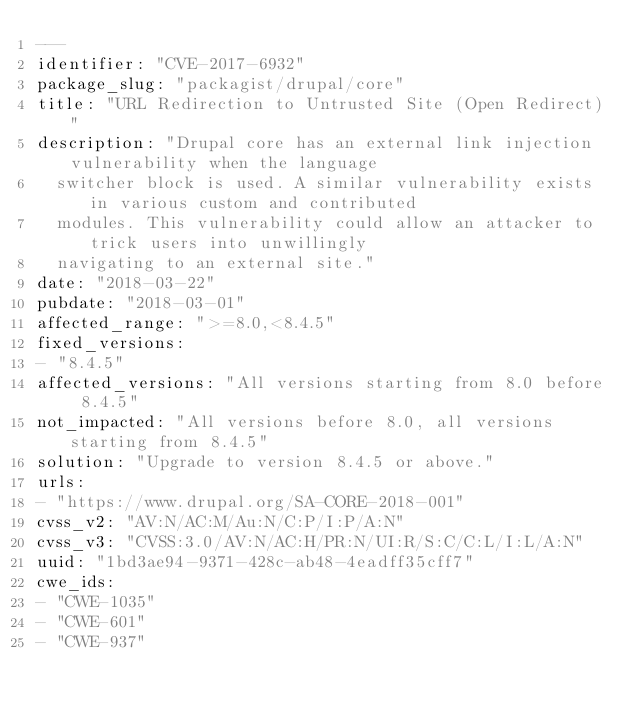Convert code to text. <code><loc_0><loc_0><loc_500><loc_500><_YAML_>---
identifier: "CVE-2017-6932"
package_slug: "packagist/drupal/core"
title: "URL Redirection to Untrusted Site (Open Redirect)"
description: "Drupal core has an external link injection vulnerability when the language
  switcher block is used. A similar vulnerability exists in various custom and contributed
  modules. This vulnerability could allow an attacker to trick users into unwillingly
  navigating to an external site."
date: "2018-03-22"
pubdate: "2018-03-01"
affected_range: ">=8.0,<8.4.5"
fixed_versions:
- "8.4.5"
affected_versions: "All versions starting from 8.0 before 8.4.5"
not_impacted: "All versions before 8.0, all versions starting from 8.4.5"
solution: "Upgrade to version 8.4.5 or above."
urls:
- "https://www.drupal.org/SA-CORE-2018-001"
cvss_v2: "AV:N/AC:M/Au:N/C:P/I:P/A:N"
cvss_v3: "CVSS:3.0/AV:N/AC:H/PR:N/UI:R/S:C/C:L/I:L/A:N"
uuid: "1bd3ae94-9371-428c-ab48-4eadff35cff7"
cwe_ids:
- "CWE-1035"
- "CWE-601"
- "CWE-937"
</code> 